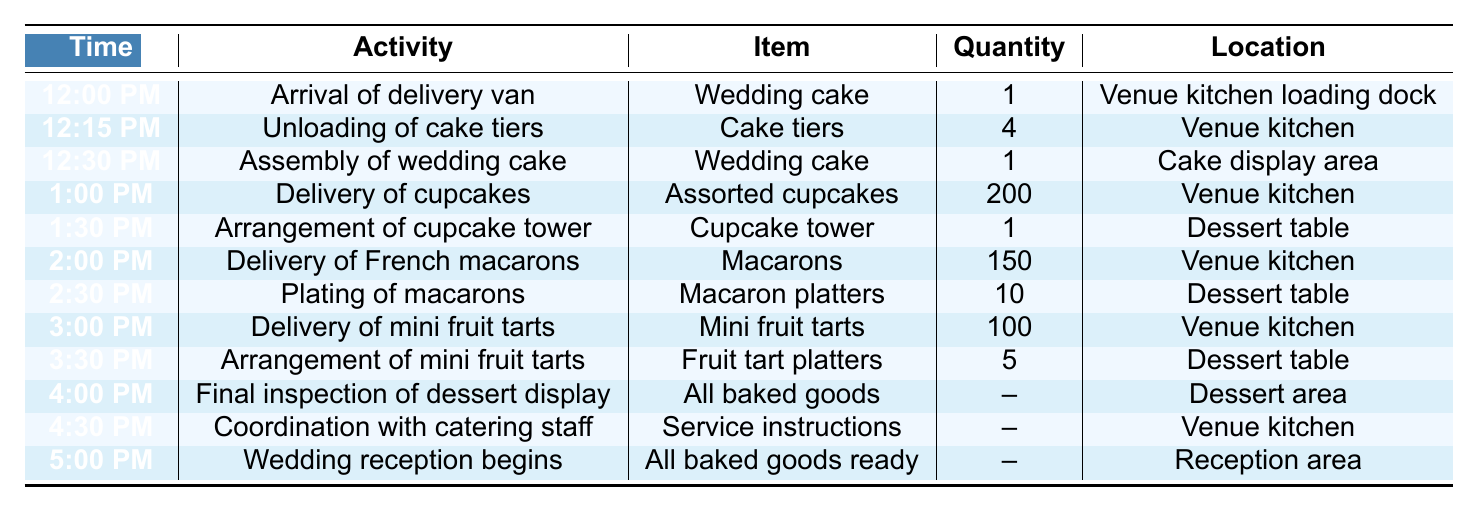What time does the delivery van from Sweet Delights Bakery arrive? The table shows that the delivery van arrives at 12:00 PM, as indicated in the "Time" column for the first row of activities.
Answer: 12:00 PM How many assorted cupcakes are delivered? The quantity of assorted cupcakes delivered is listed as 200, found in the "Quantity" column for the delivery entry at 1:00 PM.
Answer: 200 What is the last activity listed before the wedding reception begins? The last activity listed before the wedding reception at 5:00 PM is the coordination with catering staff at 4:30 PM, as shown in the "Time" column and the corresponding activity.
Answer: Coordination with catering staff How many different types of baked goods are delivered to the venue? There are four different types of baked goods: wedding cake, assorted cupcakes, French macarons, and mini fruit tarts, as indicated by the distinct items listed in the table.
Answer: Four What time is the final inspection of the dessert display scheduled? The final inspection of the dessert display is scheduled for 4:00 PM, which can be found in the "Time" column next to that specific activity.
Answer: 4:00 PM How many items are delivered in total? To find the total number of items delivered, we can add the quantities: 1 (wedding cake) + 200 (cupcakes) + 150 (macarons) + 100 (mini fruit tarts) = 451. The sum calculates the total for all delivery entries.
Answer: 451 Is the wedding cake displayed in the dessert area? The wedding cake is assembled at the cake display area, not in the dessert area, as per the locations specified in the table for those activities.
Answer: No What time is the delivery of mini fruit tarts? The delivery of mini fruit tarts is scheduled for 3:00 PM, as indicated in the "Time" column for that specific item.
Answer: 3:00 PM What is the quantity of macaron platters plated? The quantity of macaron platters plated is 10, which is noted in the "Quantity" column next to the plating activity scheduled at 2:30 PM.
Answer: 10 At what time do all baked goods become ready for the wedding reception? All baked goods are ready for the wedding reception at 5:00 PM, which is mentioned in the "Time" column for that activity.
Answer: 5:00 PM Which baked good has the highest quantity delivered? The assorted cupcakes have the highest quantity delivered, with 200 units, indicated in the "Quantity" column for that delivery.
Answer: Assorted cupcakes What activities occur between 1:00 PM and 3:00 PM? The activities from 1:00 PM to 3:00 PM are delivery of cupcakes at 1:00 PM, arrangement of cupcake tower at 1:30 PM, delivery of French macarons at 2:00 PM, and plating of macarons at 2:30 PM, as per the corresponding entries in the table.
Answer: Delivery of cupcakes, arrangement of cupcake tower, delivery of French macarons, plating of macarons How much time elapses from the unloading of cake tiers to the delivery of mini fruit tarts? The unloading starts at 12:15 PM and the mini fruit tarts are delivered at 3:00 PM. The elapsed time is 2 hours and 45 minutes, obtained by calculating the difference between these two times.
Answer: 2 hours and 45 minutes 